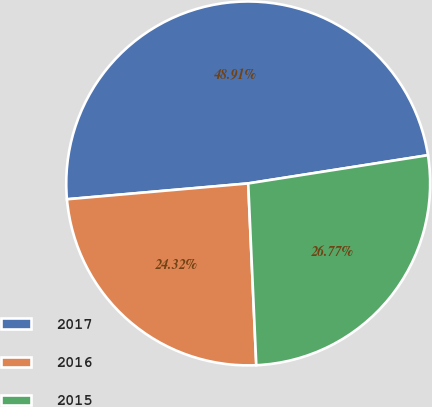<chart> <loc_0><loc_0><loc_500><loc_500><pie_chart><fcel>2017<fcel>2016<fcel>2015<nl><fcel>48.91%<fcel>24.32%<fcel>26.77%<nl></chart> 